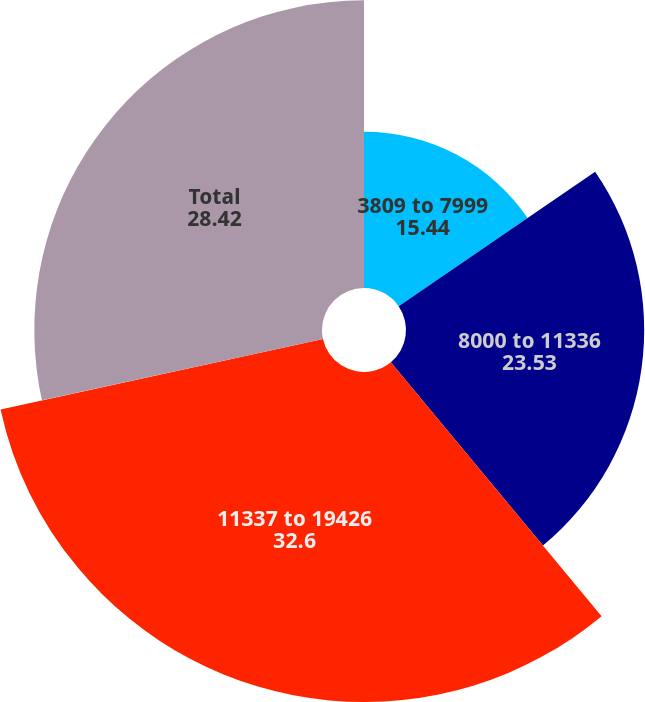Convert chart to OTSL. <chart><loc_0><loc_0><loc_500><loc_500><pie_chart><fcel>3809 to 7999<fcel>8000 to 11336<fcel>11337 to 19426<fcel>Total<nl><fcel>15.44%<fcel>23.53%<fcel>32.6%<fcel>28.42%<nl></chart> 